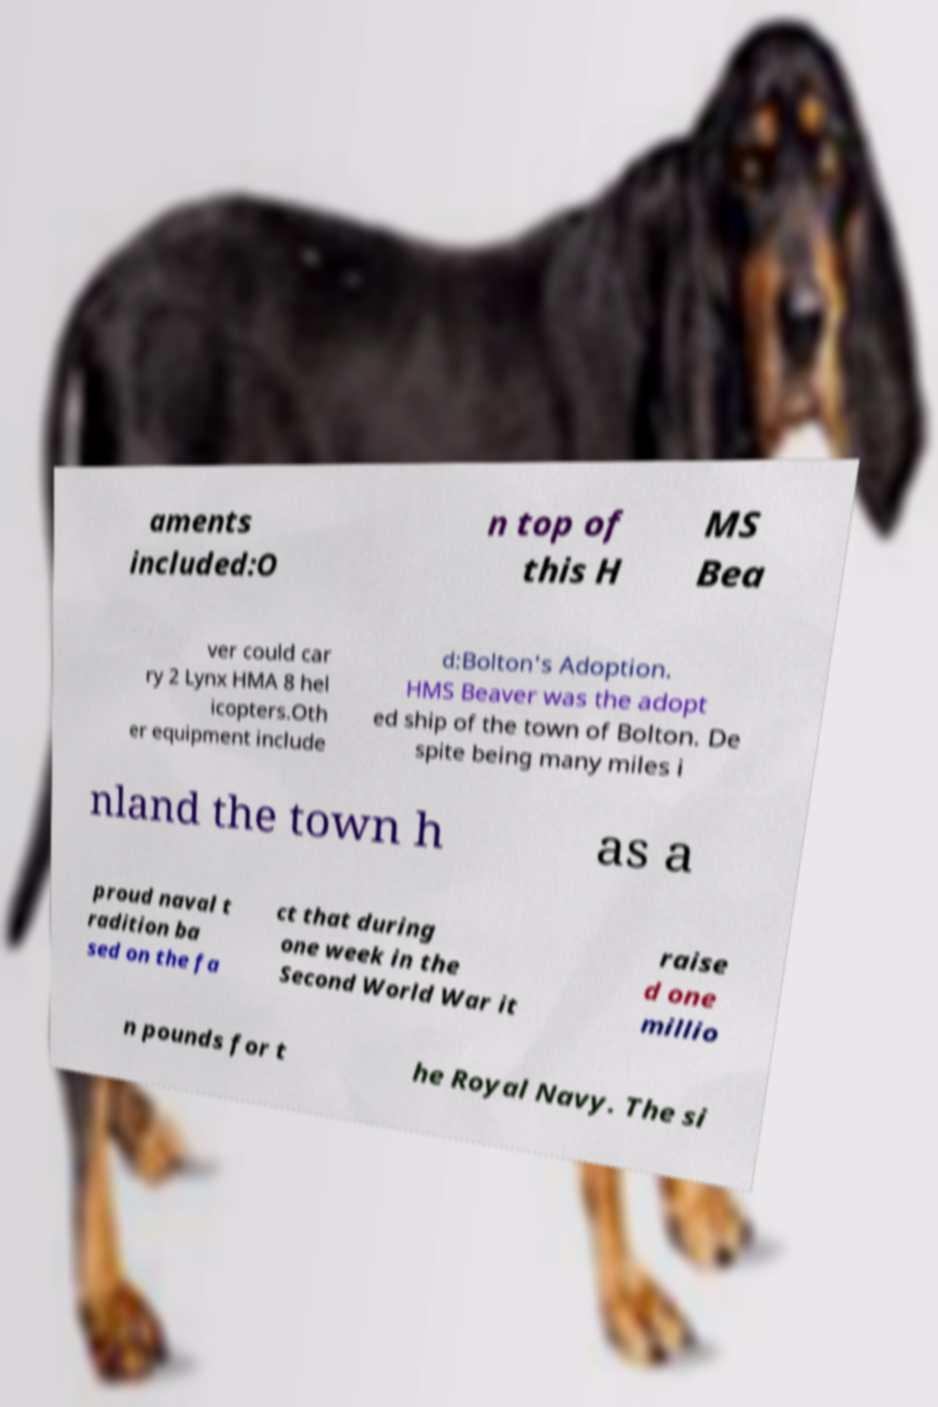Could you extract and type out the text from this image? aments included:O n top of this H MS Bea ver could car ry 2 Lynx HMA 8 hel icopters.Oth er equipment include d:Bolton's Adoption. HMS Beaver was the adopt ed ship of the town of Bolton. De spite being many miles i nland the town h as a proud naval t radition ba sed on the fa ct that during one week in the Second World War it raise d one millio n pounds for t he Royal Navy. The si 